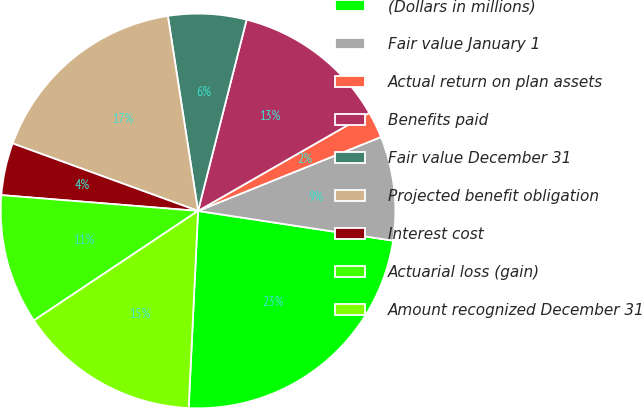Convert chart to OTSL. <chart><loc_0><loc_0><loc_500><loc_500><pie_chart><fcel>(Dollars in millions)<fcel>Fair value January 1<fcel>Actual return on plan assets<fcel>Benefits paid<fcel>Fair value December 31<fcel>Projected benefit obligation<fcel>Interest cost<fcel>Actuarial loss (gain)<fcel>Amount recognized December 31<nl><fcel>23.35%<fcel>8.52%<fcel>2.17%<fcel>12.76%<fcel>6.4%<fcel>17.0%<fcel>4.28%<fcel>10.64%<fcel>14.88%<nl></chart> 